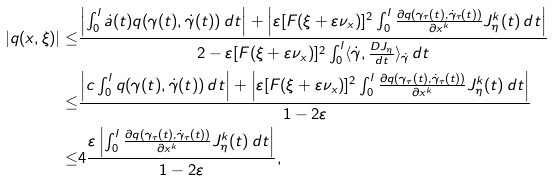<formula> <loc_0><loc_0><loc_500><loc_500>| q ( x , \xi ) | \leq & \frac { \left | \int _ { 0 } ^ { l } \dot { a } ( t ) q ( \gamma ( t ) , \dot { \gamma } ( t ) ) \, d t \right | + \left | \varepsilon [ F ( \xi + \varepsilon \nu _ { x } ) ] ^ { 2 } \int _ { 0 } ^ { l } \frac { \partial q ( \gamma _ { \tau } ( t ) , \dot { \gamma } _ { \tau } ( t ) ) } { \partial x ^ { k } } J _ { \eta } ^ { k } ( t ) \, d t \right | } { 2 - \varepsilon [ F ( \xi + \varepsilon \nu _ { x } ) ] ^ { 2 } \int _ { 0 } ^ { l } \langle \dot { \gamma } , \frac { D J _ { \eta } } { d t } \rangle _ { \dot { \gamma } } \, d t } \\ \leq & \frac { \left | c \int _ { 0 } ^ { l } q ( \gamma ( t ) , \dot { \gamma } ( t ) ) \, d t \right | + \left | \varepsilon [ F ( \xi + \varepsilon \nu _ { x } ) ] ^ { 2 } \int _ { 0 } ^ { l } \frac { \partial q ( \gamma _ { \tau } ( t ) , \dot { \gamma } _ { \tau } ( t ) ) } { \partial x ^ { k } } J _ { \eta } ^ { k } ( t ) \, d t \right | } { 1 - 2 \varepsilon } \\ \leq & 4 \frac { \varepsilon \left | \int _ { 0 } ^ { l } \frac { \partial q ( \gamma _ { \tau } ( t ) , \dot { \gamma } _ { \tau } ( t ) ) } { \partial x ^ { k } } J _ { \eta } ^ { k } ( t ) \, d t \right | } { 1 - 2 \varepsilon } ,</formula> 